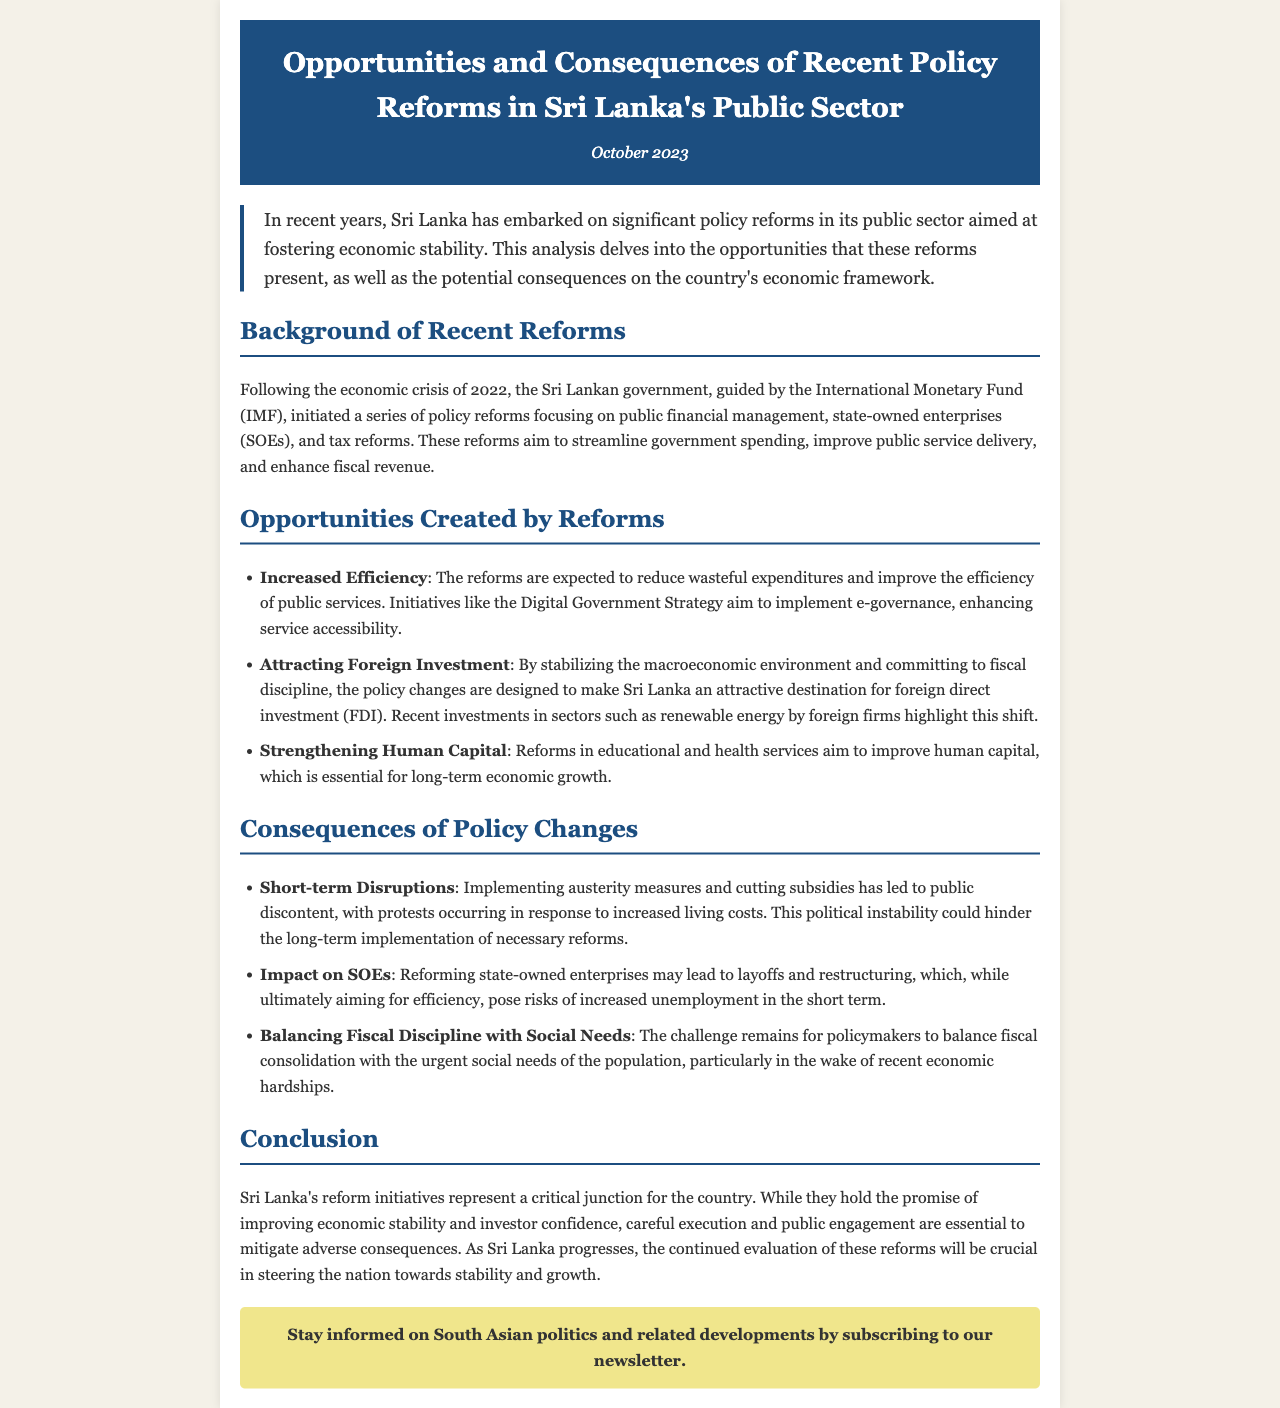What is the title of the newsletter? The title of the newsletter is presented in the header section.
Answer: Opportunities and Consequences of Recent Policy Reforms in Sri Lanka's Public Sector When was the newsletter published? The publication date is indicated right below the title in the header.
Answer: October 2023 What are the three main areas of focus for the policy reforms? The areas are detailed in the background section of the newsletter.
Answer: Public financial management, state-owned enterprises (SOEs), and tax reforms What is one initiative mentioned that aims to enhance service accessibility? The initiative is listed under the opportunities section related to increased efficiency.
Answer: Digital Government Strategy What is a potential short-term consequence of the policy changes? This consequence is highlighted in the consequences section of the newsletter.
Answer: Short-term Disruptions According to the newsletter, what challenge do policymakers face? The challenge is discussed at the end of the consequences section.
Answer: Balancing fiscal discipline with social needs What sector has seen recent foreign investments? The sector is mentioned as an example of the opportunities created by the reforms.
Answer: Renewable energy What is crucial for the success of Sri Lanka's reform initiatives? This point is emphasized in the conclusion of the newsletter.
Answer: Careful execution and public engagement 